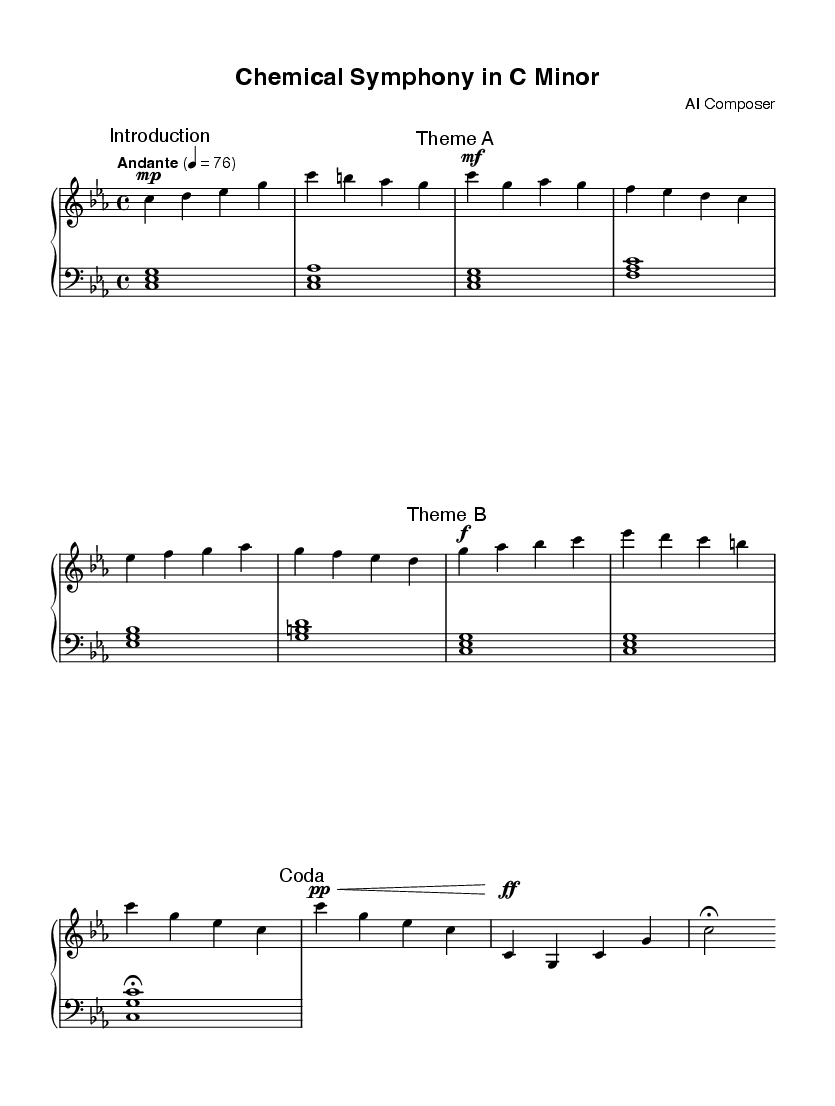What is the key signature of this music? The key signature indicates the key of C minor, which has three flats: B flat, E flat, and A flat. This can be identified by looking at the key signature at the beginning of the sheet music.
Answer: C minor What is the time signature of this music? The time signature shown in the sheet music is 4/4, meaning there are four beats in each measure, and each beat is represented by a quarter note. This can usually be found at the beginning of the music.
Answer: 4/4 What is the tempo marking for this piece? The tempo marking "Andante" is at the beginning, indicating a moderate pace, with a specific beats-per-minute indication as 76. This can be seen alongside the tempo indication at the start of the sheet music.
Answer: Andante, 76 How many distinct themes are presented in the music? There are two distinct themes present in the composition, labeled as Theme A and Theme B in the score. The thematic sections are marked within the music, making it clear that there are two main ideas explored.
Answer: Two What dynamics are used in Theme A? The dynamics in Theme A include a mezzo-forte marking for the first phrase and a crescendo leading to a mezzo-piano section later. This can be identified by the dynamic markings adjacent to the notes in the Theme A section.
Answer: Mezzo-forte and crescendo Which section of the music is labeled as the Coda? The Coda is labeled as such near the end of the score, indicating that it is the concluding section of the piece. It can be identified by both the label and its placement at the end of the musical ideas.
Answer: Coda What is the final dynamic marking in the music? The final dynamic marking in the piece is a fortissimo marking, indicating that this section should be played very loudly. This can be seen at the end of the Coda, just before the fermata.
Answer: Fortissimo 